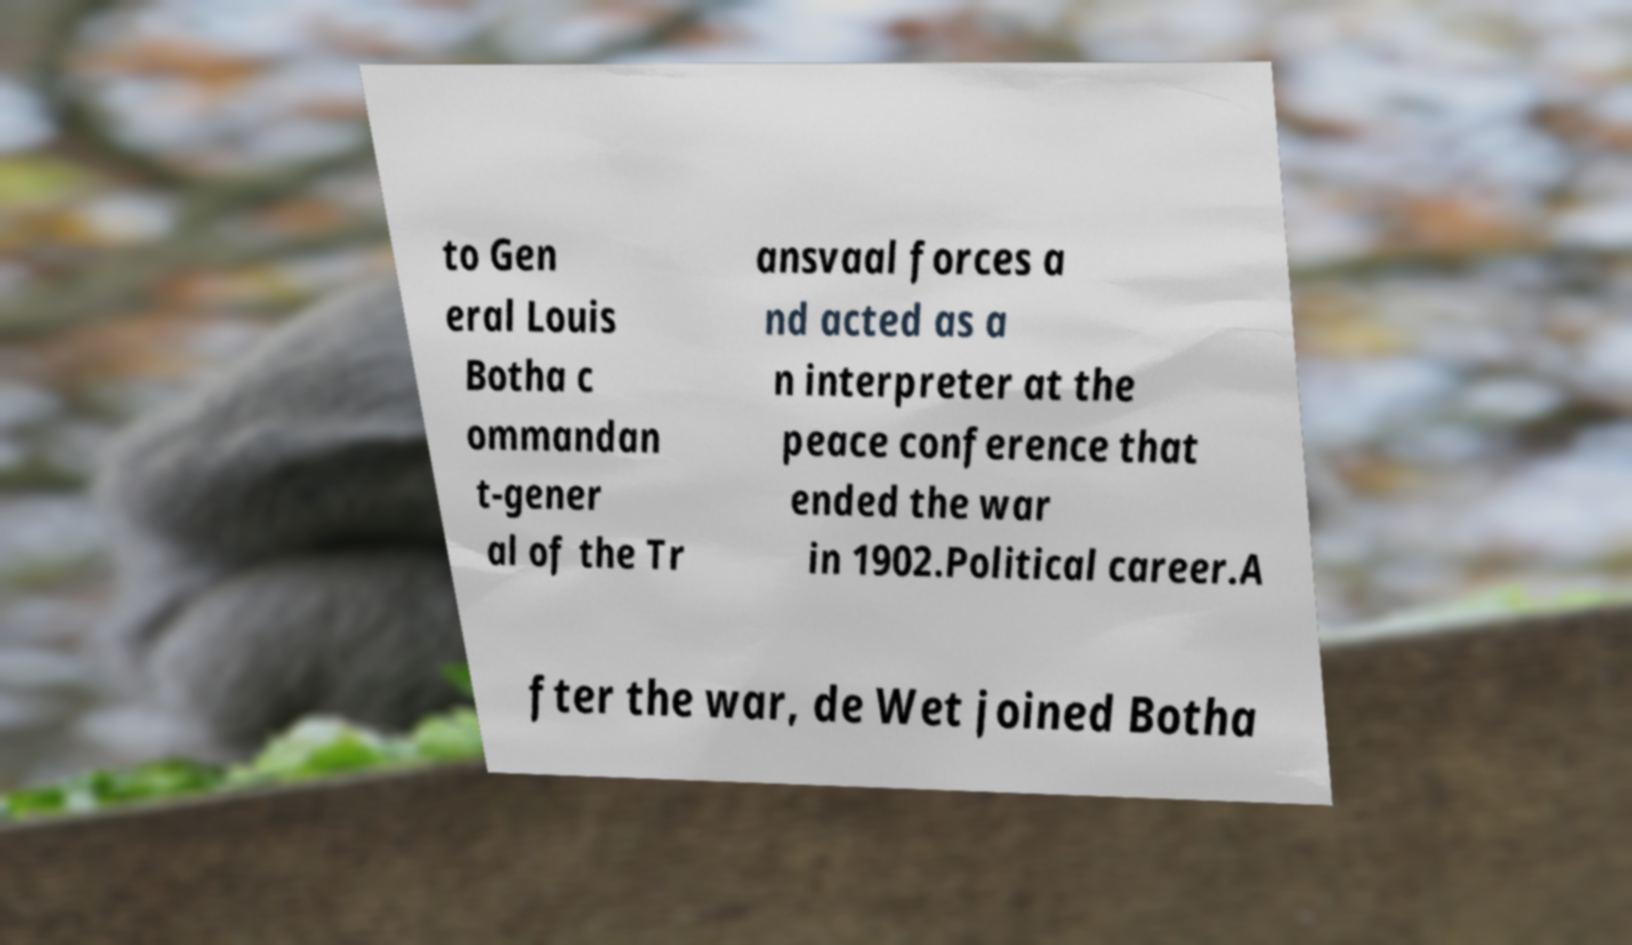Please identify and transcribe the text found in this image. to Gen eral Louis Botha c ommandan t-gener al of the Tr ansvaal forces a nd acted as a n interpreter at the peace conference that ended the war in 1902.Political career.A fter the war, de Wet joined Botha 